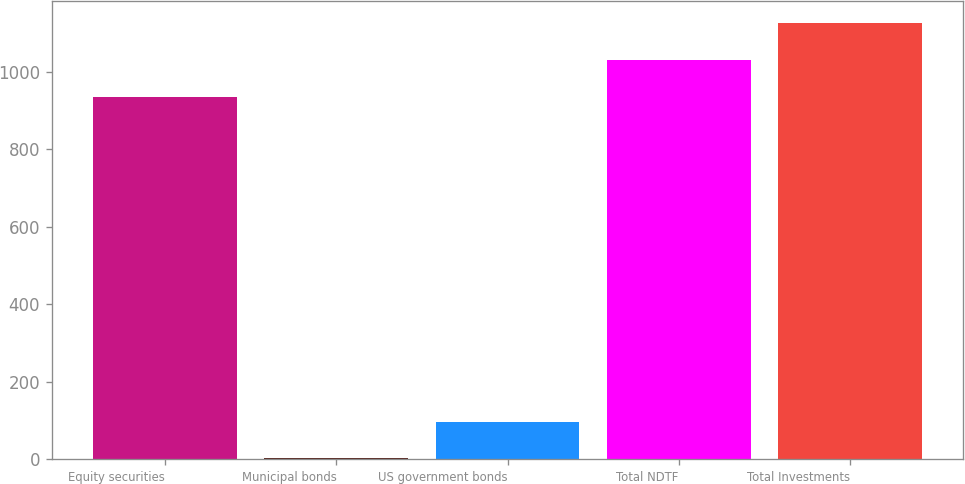Convert chart. <chart><loc_0><loc_0><loc_500><loc_500><bar_chart><fcel>Equity securities<fcel>Municipal bonds<fcel>US government bonds<fcel>Total NDTF<fcel>Total Investments<nl><fcel>935<fcel>2<fcel>97<fcel>1030<fcel>1125<nl></chart> 